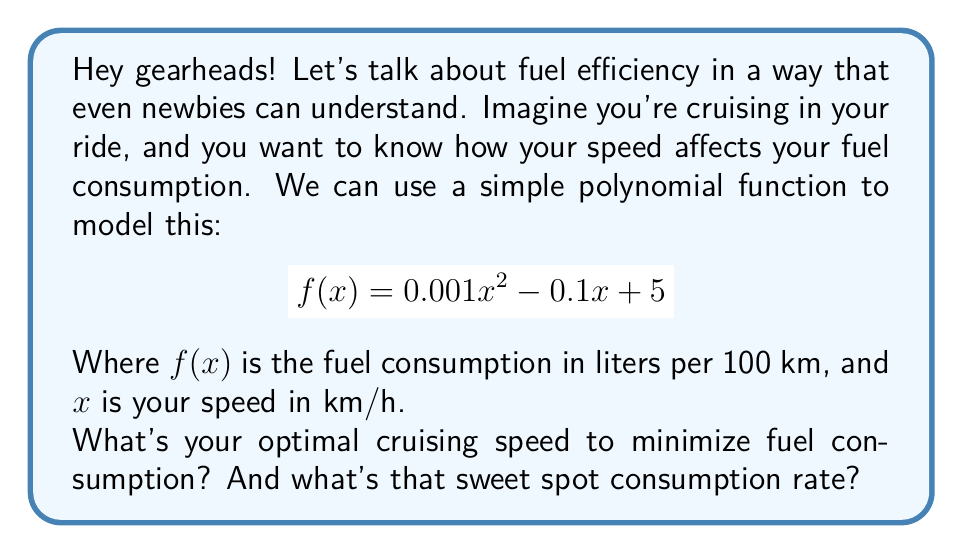Help me with this question. Alright, let's break this down step-by-step:

1) To find the optimal speed for minimum fuel consumption, we need to find the minimum point of the function. In calculus terms, this is where the derivative of the function equals zero.

2) The derivative of $f(x)$ is:
   $$f'(x) = 0.002x - 0.1$$

3) Set this equal to zero and solve for x:
   $$0.002x - 0.1 = 0$$
   $$0.002x = 0.1$$
   $$x = 50$$

4) This means the optimal speed is 50 km/h.

5) To find the fuel consumption at this speed, we plug 50 back into our original function:
   $$f(50) = 0.001(50)^2 - 0.1(50) + 5$$
   $$= 0.001(2500) - 5 + 5$$
   $$= 2.5 - 5 + 5 = 2.5$$

So, at 50 km/h, you're using 2.5 liters per 100 km.
Answer: Optimal speed: 50 km/h; Minimum fuel consumption: 2.5 L/100km 